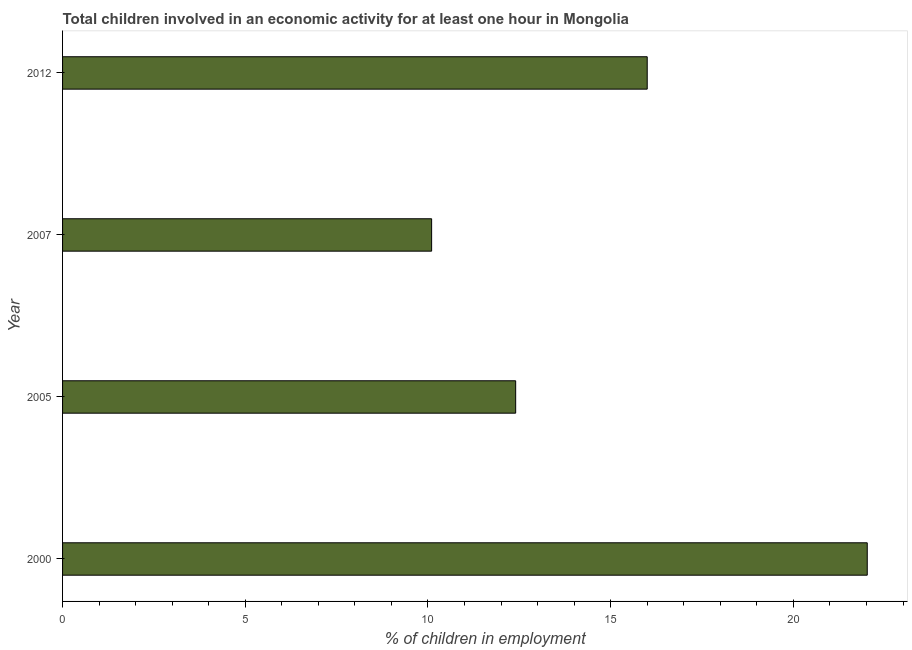What is the title of the graph?
Provide a succinct answer. Total children involved in an economic activity for at least one hour in Mongolia. What is the label or title of the X-axis?
Provide a succinct answer. % of children in employment. What is the label or title of the Y-axis?
Your response must be concise. Year. What is the percentage of children in employment in 2000?
Make the answer very short. 22.02. Across all years, what is the maximum percentage of children in employment?
Give a very brief answer. 22.02. What is the sum of the percentage of children in employment?
Ensure brevity in your answer.  60.52. What is the difference between the percentage of children in employment in 2005 and 2012?
Your answer should be compact. -3.6. What is the average percentage of children in employment per year?
Offer a very short reply. 15.13. In how many years, is the percentage of children in employment greater than 15 %?
Your answer should be compact. 2. Do a majority of the years between 2000 and 2012 (inclusive) have percentage of children in employment greater than 19 %?
Provide a short and direct response. No. What is the ratio of the percentage of children in employment in 2007 to that in 2012?
Your response must be concise. 0.63. Is the percentage of children in employment in 2005 less than that in 2007?
Provide a succinct answer. No. Is the difference between the percentage of children in employment in 2000 and 2012 greater than the difference between any two years?
Offer a very short reply. No. What is the difference between the highest and the second highest percentage of children in employment?
Provide a short and direct response. 6.02. Is the sum of the percentage of children in employment in 2000 and 2007 greater than the maximum percentage of children in employment across all years?
Offer a very short reply. Yes. What is the difference between the highest and the lowest percentage of children in employment?
Make the answer very short. 11.92. In how many years, is the percentage of children in employment greater than the average percentage of children in employment taken over all years?
Your answer should be very brief. 2. How many bars are there?
Make the answer very short. 4. What is the difference between two consecutive major ticks on the X-axis?
Your response must be concise. 5. Are the values on the major ticks of X-axis written in scientific E-notation?
Ensure brevity in your answer.  No. What is the % of children in employment in 2000?
Give a very brief answer. 22.02. What is the % of children in employment of 2007?
Your response must be concise. 10.1. What is the % of children in employment in 2012?
Ensure brevity in your answer.  16. What is the difference between the % of children in employment in 2000 and 2005?
Provide a succinct answer. 9.62. What is the difference between the % of children in employment in 2000 and 2007?
Your answer should be very brief. 11.92. What is the difference between the % of children in employment in 2000 and 2012?
Your response must be concise. 6.02. What is the difference between the % of children in employment in 2005 and 2012?
Make the answer very short. -3.6. What is the ratio of the % of children in employment in 2000 to that in 2005?
Offer a terse response. 1.78. What is the ratio of the % of children in employment in 2000 to that in 2007?
Your answer should be very brief. 2.18. What is the ratio of the % of children in employment in 2000 to that in 2012?
Offer a very short reply. 1.38. What is the ratio of the % of children in employment in 2005 to that in 2007?
Provide a succinct answer. 1.23. What is the ratio of the % of children in employment in 2005 to that in 2012?
Provide a succinct answer. 0.78. What is the ratio of the % of children in employment in 2007 to that in 2012?
Your answer should be compact. 0.63. 